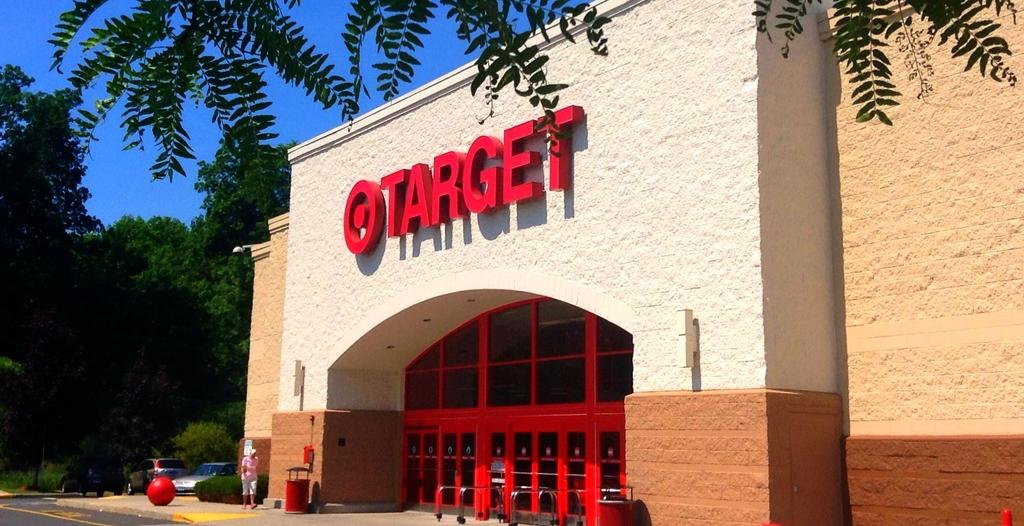What type of structure is present in the image? There is a building in the image. What other natural elements can be seen in the image? There are trees in the image. Are there any vehicles visible in the image? Yes, there are cars in the image. What is the person in the image doing? There is a person walking on the ground in the image. What can be seen in the background of the image? The sky is visible in the background of the image. Can you tell me where the office is located in the image? There is no office mentioned or visible in the image. Who is the guide in the image? There is no guide present in the image. 